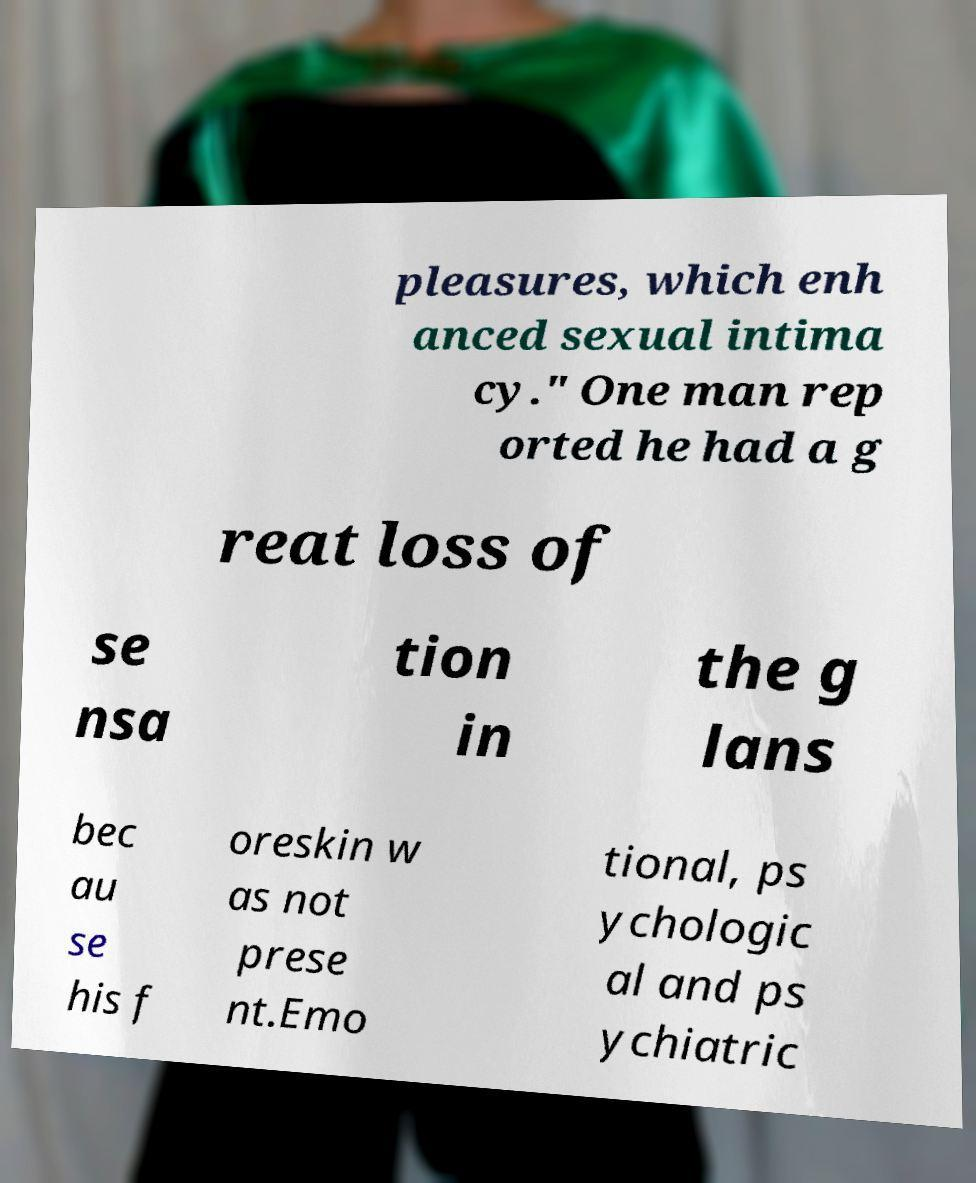For documentation purposes, I need the text within this image transcribed. Could you provide that? pleasures, which enh anced sexual intima cy." One man rep orted he had a g reat loss of se nsa tion in the g lans bec au se his f oreskin w as not prese nt.Emo tional, ps ychologic al and ps ychiatric 